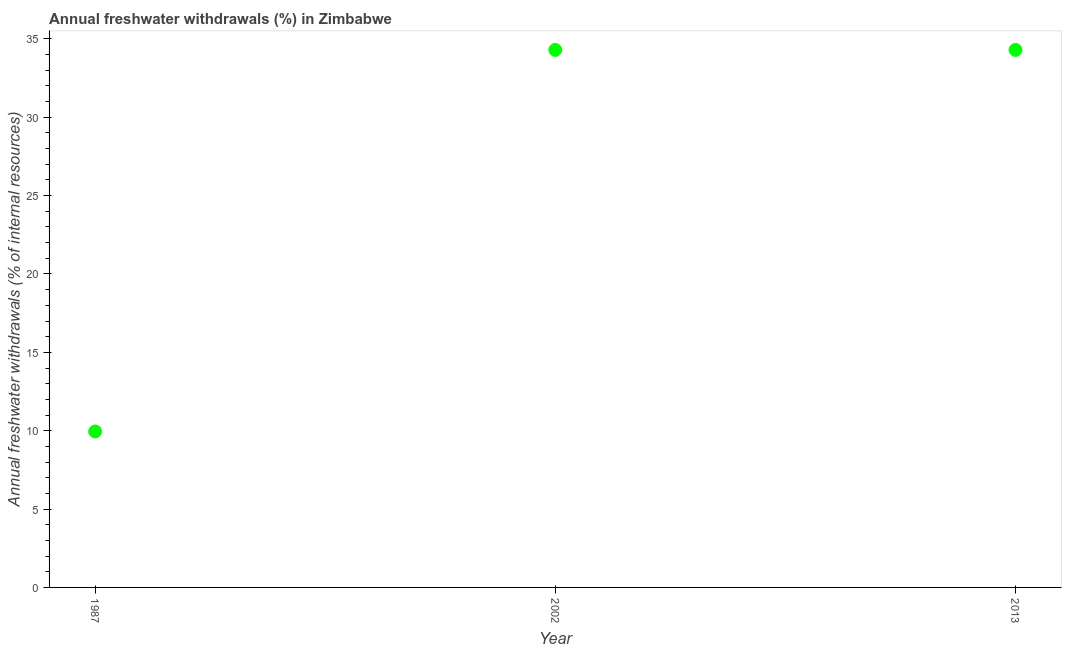What is the annual freshwater withdrawals in 2013?
Offer a very short reply. 34.3. Across all years, what is the maximum annual freshwater withdrawals?
Make the answer very short. 34.3. Across all years, what is the minimum annual freshwater withdrawals?
Your response must be concise. 9.95. In which year was the annual freshwater withdrawals minimum?
Provide a short and direct response. 1987. What is the sum of the annual freshwater withdrawals?
Provide a succinct answer. 78.55. What is the average annual freshwater withdrawals per year?
Provide a succinct answer. 26.18. What is the median annual freshwater withdrawals?
Offer a very short reply. 34.3. In how many years, is the annual freshwater withdrawals greater than 31 %?
Your response must be concise. 2. Do a majority of the years between 1987 and 2002 (inclusive) have annual freshwater withdrawals greater than 5 %?
Your answer should be very brief. Yes. What is the ratio of the annual freshwater withdrawals in 1987 to that in 2002?
Your answer should be compact. 0.29. What is the difference between the highest and the second highest annual freshwater withdrawals?
Your answer should be compact. 0. Is the sum of the annual freshwater withdrawals in 1987 and 2002 greater than the maximum annual freshwater withdrawals across all years?
Give a very brief answer. Yes. What is the difference between the highest and the lowest annual freshwater withdrawals?
Provide a short and direct response. 24.35. How many dotlines are there?
Give a very brief answer. 1. Does the graph contain any zero values?
Offer a terse response. No. Does the graph contain grids?
Keep it short and to the point. No. What is the title of the graph?
Provide a succinct answer. Annual freshwater withdrawals (%) in Zimbabwe. What is the label or title of the Y-axis?
Make the answer very short. Annual freshwater withdrawals (% of internal resources). What is the Annual freshwater withdrawals (% of internal resources) in 1987?
Keep it short and to the point. 9.95. What is the Annual freshwater withdrawals (% of internal resources) in 2002?
Make the answer very short. 34.3. What is the Annual freshwater withdrawals (% of internal resources) in 2013?
Give a very brief answer. 34.3. What is the difference between the Annual freshwater withdrawals (% of internal resources) in 1987 and 2002?
Provide a short and direct response. -24.35. What is the difference between the Annual freshwater withdrawals (% of internal resources) in 1987 and 2013?
Your response must be concise. -24.35. What is the ratio of the Annual freshwater withdrawals (% of internal resources) in 1987 to that in 2002?
Offer a terse response. 0.29. What is the ratio of the Annual freshwater withdrawals (% of internal resources) in 1987 to that in 2013?
Provide a succinct answer. 0.29. 